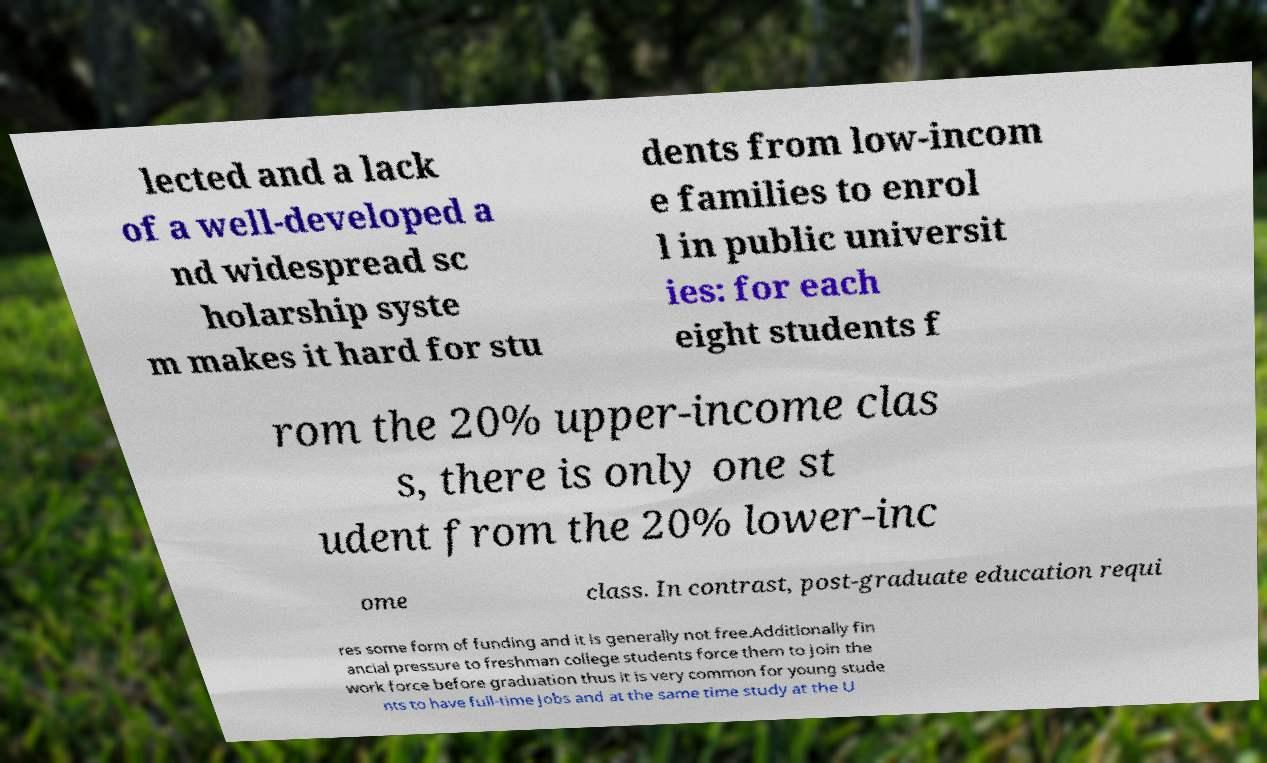Please identify and transcribe the text found in this image. lected and a lack of a well-developed a nd widespread sc holarship syste m makes it hard for stu dents from low-incom e families to enrol l in public universit ies: for each eight students f rom the 20% upper-income clas s, there is only one st udent from the 20% lower-inc ome class. In contrast, post-graduate education requi res some form of funding and it is generally not free.Additionally fin ancial pressure to freshman college students force them to join the work force before graduation thus it is very common for young stude nts to have full-time jobs and at the same time study at the U 